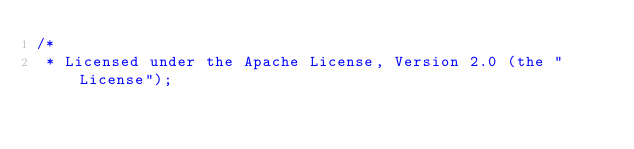<code> <loc_0><loc_0><loc_500><loc_500><_Java_>/*
 * Licensed under the Apache License, Version 2.0 (the "License");</code> 